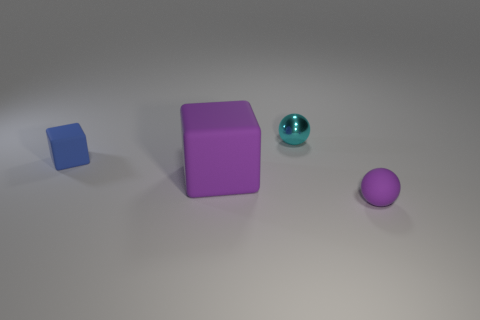Are there any other things that are the same size as the purple cube?
Your answer should be very brief. No. What is the size of the purple thing that is on the left side of the ball that is in front of the tiny matte thing left of the tiny purple rubber object?
Ensure brevity in your answer.  Large. Is the size of the sphere that is behind the matte ball the same as the tiny blue cube?
Make the answer very short. Yes. How many other objects are the same material as the cyan ball?
Offer a terse response. 0. Is the number of blue things greater than the number of large gray rubber spheres?
Offer a very short reply. Yes. What is the material of the tiny thing that is behind the tiny block behind the purple object that is right of the big purple matte object?
Ensure brevity in your answer.  Metal. Does the tiny shiny object have the same color as the small matte sphere?
Provide a short and direct response. No. Is there a big cube that has the same color as the matte sphere?
Provide a short and direct response. Yes. There is a purple rubber object that is the same size as the metal sphere; what is its shape?
Your answer should be very brief. Sphere. Are there fewer tiny objects than tiny matte balls?
Give a very brief answer. No. 